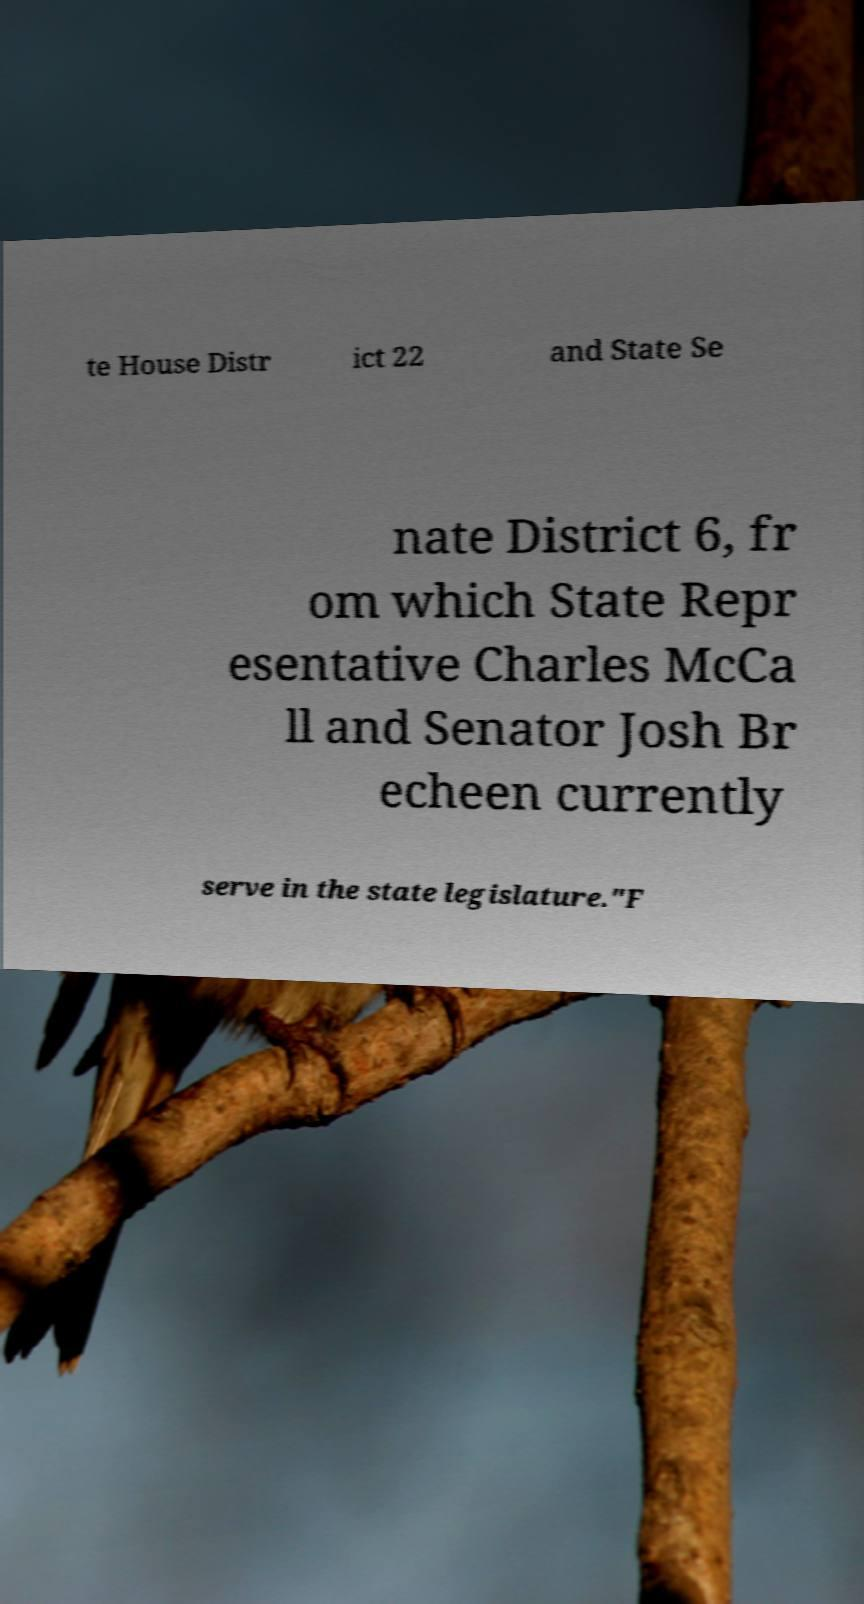I need the written content from this picture converted into text. Can you do that? te House Distr ict 22 and State Se nate District 6, fr om which State Repr esentative Charles McCa ll and Senator Josh Br echeen currently serve in the state legislature."F 